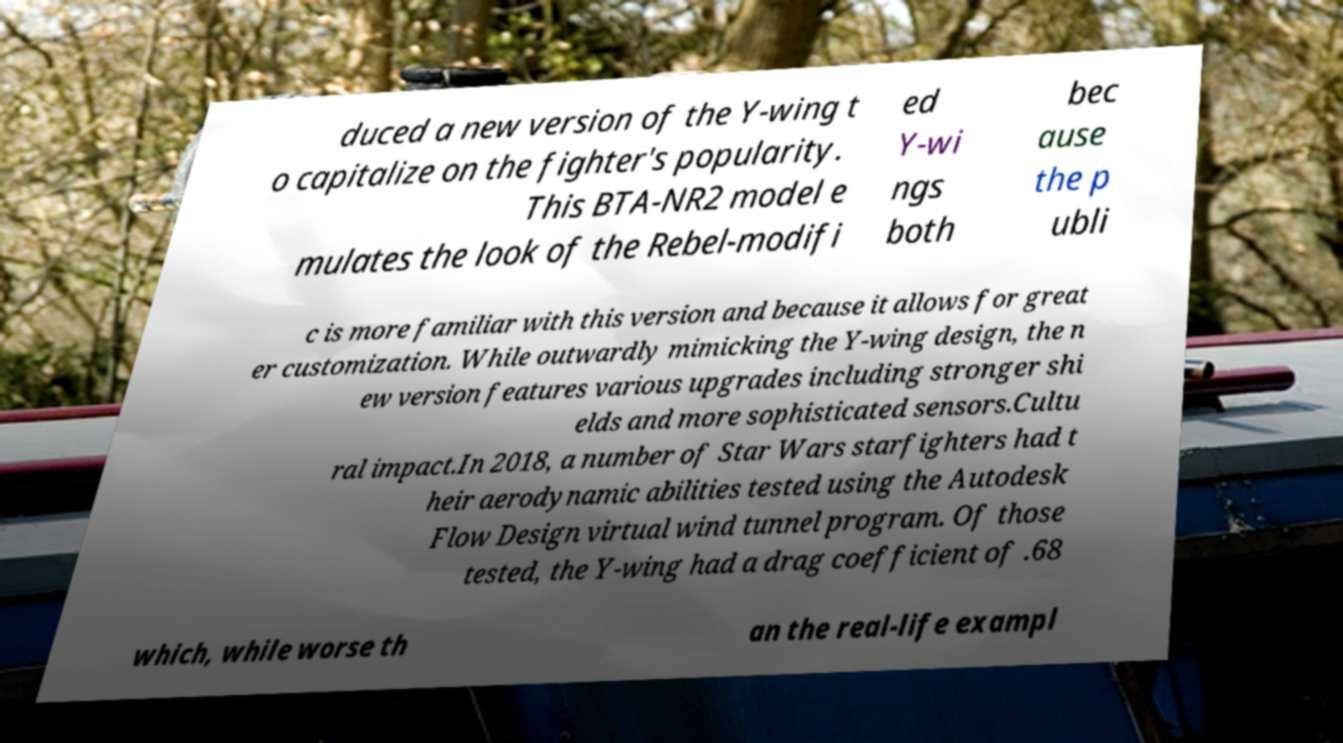Could you assist in decoding the text presented in this image and type it out clearly? duced a new version of the Y-wing t o capitalize on the fighter's popularity. This BTA-NR2 model e mulates the look of the Rebel-modifi ed Y-wi ngs both bec ause the p ubli c is more familiar with this version and because it allows for great er customization. While outwardly mimicking the Y-wing design, the n ew version features various upgrades including stronger shi elds and more sophisticated sensors.Cultu ral impact.In 2018, a number of Star Wars starfighters had t heir aerodynamic abilities tested using the Autodesk Flow Design virtual wind tunnel program. Of those tested, the Y-wing had a drag coefficient of .68 which, while worse th an the real-life exampl 